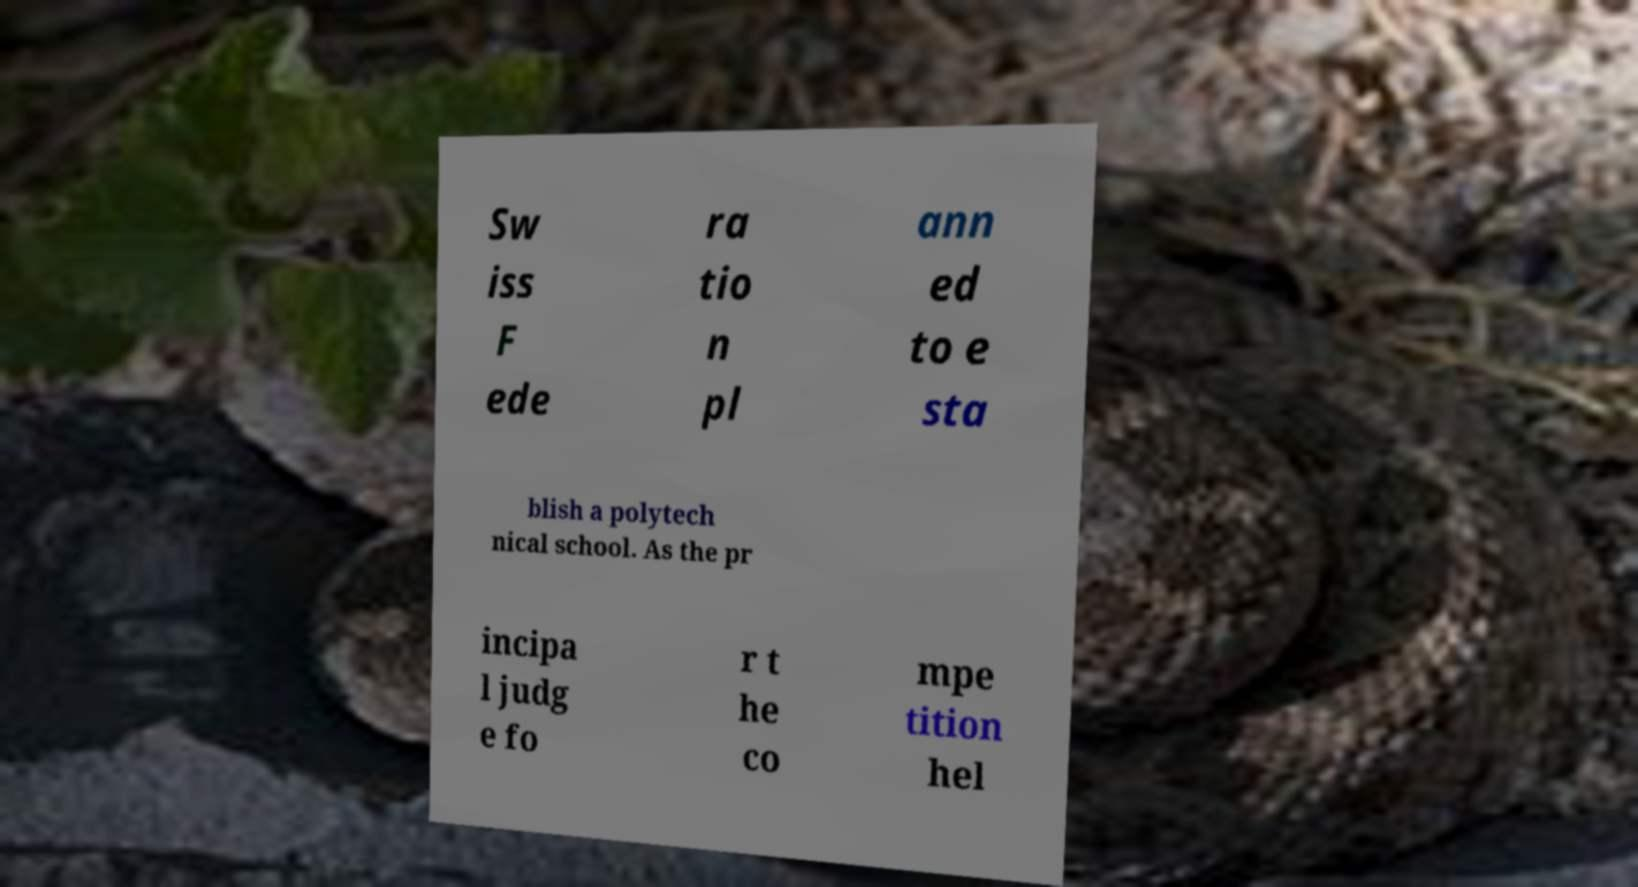Please identify and transcribe the text found in this image. Sw iss F ede ra tio n pl ann ed to e sta blish a polytech nical school. As the pr incipa l judg e fo r t he co mpe tition hel 